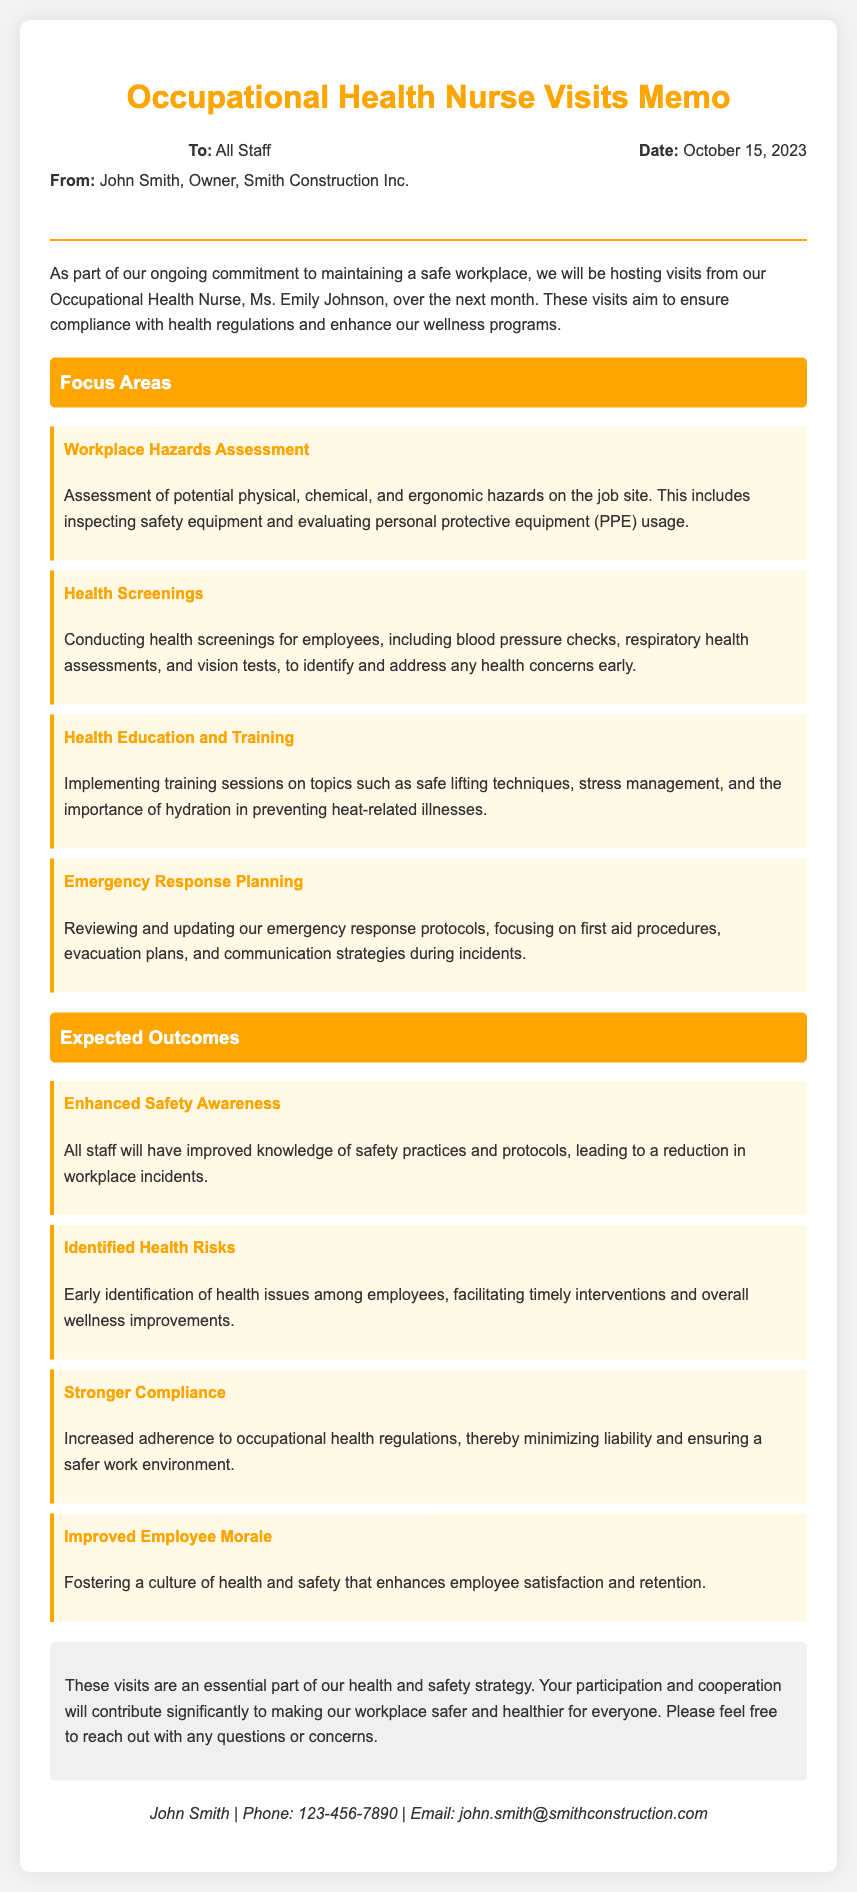What is the name of the Occupational Health Nurse? The document states the Occupational Health Nurse's name is Ms. Emily Johnson.
Answer: Ms. Emily Johnson What is the date of the memo? The memo is dated October 15, 2023.
Answer: October 15, 2023 What are the two areas included in the "Focus Areas"? The "Focus Areas" section includes Workplace Hazards Assessment and Health Screenings, among others.
Answer: Workplace Hazards Assessment, Health Screenings What is one expected outcome mentioned in the memo? The memo lists several expected outcomes, including Enhanced Safety Awareness.
Answer: Enhanced Safety Awareness How many focus areas are listed in the document? The document outlines four focus areas related to the Occupational Health Nurse visits.
Answer: Four Who is the sender of the memo? The sender of the memo is John Smith, who is the owner of Smith Construction Inc.
Answer: John Smith What primary goal does the memo emphasize? The memo emphasizes the goal of maintaining a safe workplace.
Answer: Maintaining a safe workplace What is one health screening mentioned in the memo? The document mentions blood pressure checks as a part of the health screenings conducted.
Answer: Blood pressure checks What is the expected outcome regarding employee morale? The memo states that the expected outcome is Improved Employee Morale.
Answer: Improved Employee Morale 